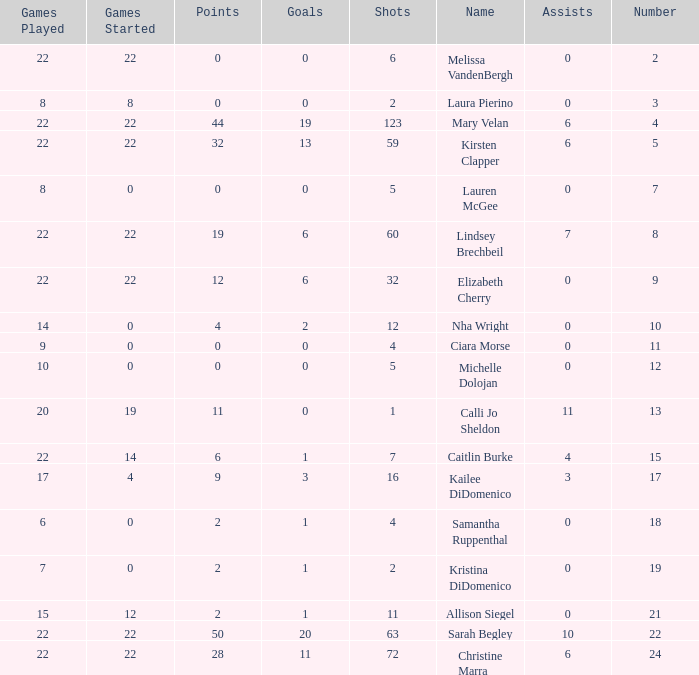Could you parse the entire table as a dict? {'header': ['Games Played', 'Games Started', 'Points', 'Goals', 'Shots', 'Name', 'Assists', 'Number'], 'rows': [['22', '22', '0', '0', '6', 'Melissa VandenBergh', '0', '2'], ['8', '8', '0', '0', '2', 'Laura Pierino', '0', '3'], ['22', '22', '44', '19', '123', 'Mary Velan', '6', '4'], ['22', '22', '32', '13', '59', 'Kirsten Clapper', '6', '5'], ['8', '0', '0', '0', '5', 'Lauren McGee', '0', '7'], ['22', '22', '19', '6', '60', 'Lindsey Brechbeil', '7', '8'], ['22', '22', '12', '6', '32', 'Elizabeth Cherry', '0', '9'], ['14', '0', '4', '2', '12', 'Nha Wright', '0', '10'], ['9', '0', '0', '0', '4', 'Ciara Morse', '0', '11'], ['10', '0', '0', '0', '5', 'Michelle Dolojan', '0', '12'], ['20', '19', '11', '0', '1', 'Calli Jo Sheldon', '11', '13'], ['22', '14', '6', '1', '7', 'Caitlin Burke', '4', '15'], ['17', '4', '9', '3', '16', 'Kailee DiDomenico', '3', '17'], ['6', '0', '2', '1', '4', 'Samantha Ruppenthal', '0', '18'], ['7', '0', '2', '1', '2', 'Kristina DiDomenico', '0', '19'], ['15', '12', '2', '1', '11', 'Allison Siegel', '0', '21'], ['22', '22', '50', '20', '63', 'Sarah Begley', '10', '22'], ['22', '22', '28', '11', '72', 'Christine Marra', '6', '24']]} How many names are listed for the player with 50 points? 1.0. 